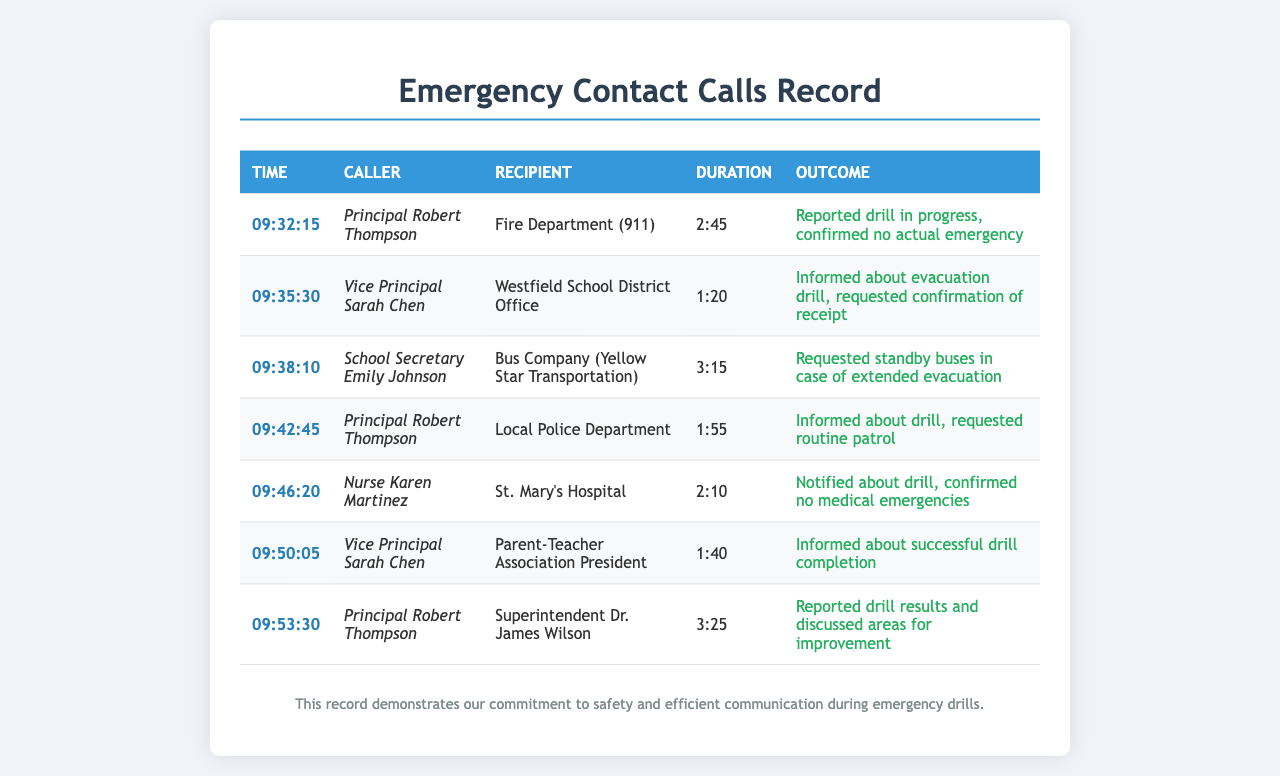What time did Principal Robert Thompson first call 911? The first call made by Principal Robert Thompson to 911 was recorded at 09:32:15.
Answer: 09:32:15 How long did the call to Yellow Star Transportation last? The duration of the call to Yellow Star Transportation was recorded as 3:15 minutes.
Answer: 3:15 Who was informed about the completion of the drill? The Parent-Teacher Association President was informed about the successful drill completion.
Answer: Parent-Teacher Association President What was the outcome of the call to St. Mary's Hospital? The outcome of the call to St. Mary's Hospital was that no medical emergencies were confirmed.
Answer: No medical emergencies How many calls did Principal Robert Thompson make during the evacuation drill? Principal Robert Thompson made a total of three calls during the evacuation drill.
Answer: Three calls What was the main reason for the call made by Nurse Karen Martinez? Nurse Karen Martinez called to notify St. Mary's Hospital about the drill and confirm no medical emergencies.
Answer: Notify about the drill What time did the Vice Principal call the Westfield School District Office? The call to the Westfield School District Office was made at 09:35:30.
Answer: 09:35:30 How many minutes did the call with Superintendent Dr. James Wilson last? The call with Superintendent Dr. James Wilson lasted 3:25 minutes.
Answer: 3:25 What did the Principal report during the call with the Superintendent? During the call with the Superintendent, the Principal reported drill results and discussed areas for improvement.
Answer: Reported drill results and discussed areas for improvement 